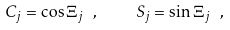Convert formula to latex. <formula><loc_0><loc_0><loc_500><loc_500>C _ { j } = \cos \Xi _ { j } \ , \quad S _ { j } = \sin \Xi _ { j } \ ,</formula> 